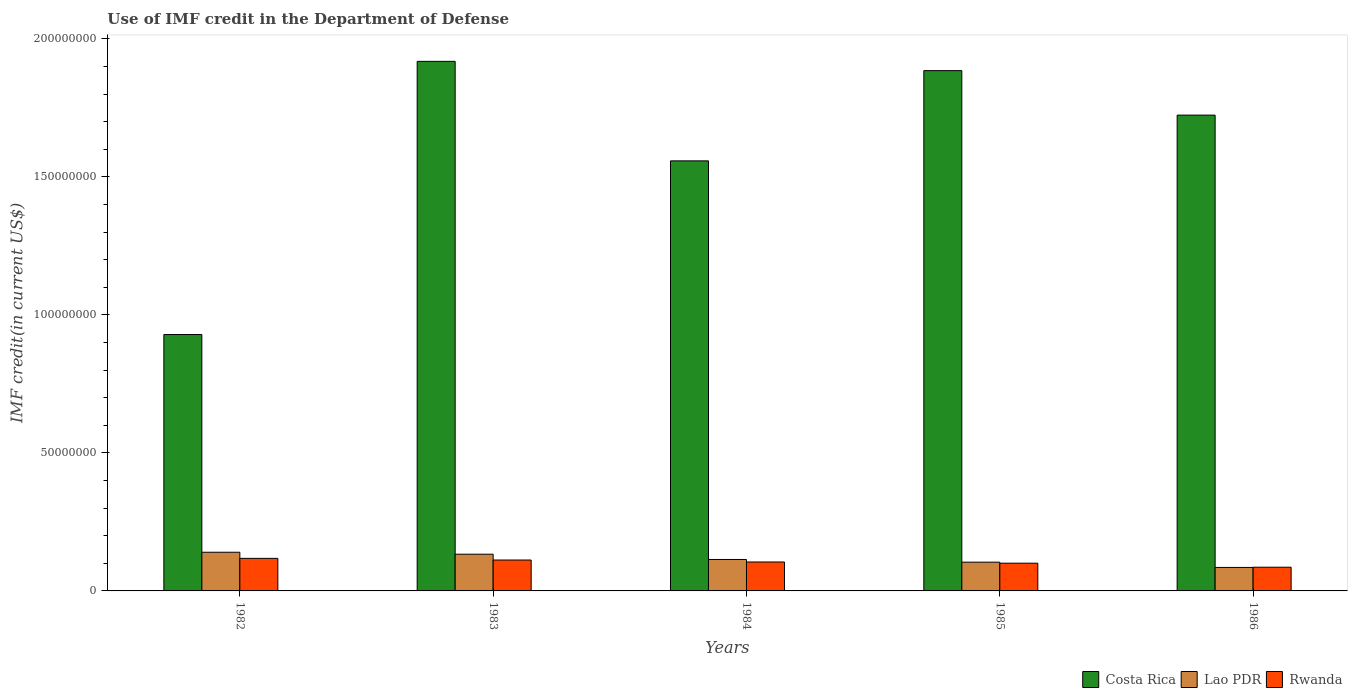How many groups of bars are there?
Provide a succinct answer. 5. Are the number of bars per tick equal to the number of legend labels?
Give a very brief answer. Yes. Are the number of bars on each tick of the X-axis equal?
Ensure brevity in your answer.  Yes. How many bars are there on the 4th tick from the right?
Provide a short and direct response. 3. In how many cases, is the number of bars for a given year not equal to the number of legend labels?
Ensure brevity in your answer.  0. What is the IMF credit in the Department of Defense in Lao PDR in 1985?
Ensure brevity in your answer.  1.04e+07. Across all years, what is the maximum IMF credit in the Department of Defense in Rwanda?
Offer a terse response. 1.18e+07. Across all years, what is the minimum IMF credit in the Department of Defense in Costa Rica?
Your response must be concise. 9.29e+07. In which year was the IMF credit in the Department of Defense in Costa Rica minimum?
Keep it short and to the point. 1982. What is the total IMF credit in the Department of Defense in Lao PDR in the graph?
Provide a succinct answer. 5.76e+07. What is the difference between the IMF credit in the Department of Defense in Lao PDR in 1982 and that in 1985?
Ensure brevity in your answer.  3.59e+06. What is the difference between the IMF credit in the Department of Defense in Costa Rica in 1985 and the IMF credit in the Department of Defense in Lao PDR in 1984?
Give a very brief answer. 1.77e+08. What is the average IMF credit in the Department of Defense in Costa Rica per year?
Offer a very short reply. 1.60e+08. In the year 1985, what is the difference between the IMF credit in the Department of Defense in Costa Rica and IMF credit in the Department of Defense in Rwanda?
Offer a terse response. 1.78e+08. In how many years, is the IMF credit in the Department of Defense in Rwanda greater than 150000000 US$?
Offer a very short reply. 0. What is the ratio of the IMF credit in the Department of Defense in Costa Rica in 1983 to that in 1985?
Offer a terse response. 1.02. Is the IMF credit in the Department of Defense in Costa Rica in 1982 less than that in 1984?
Make the answer very short. Yes. What is the difference between the highest and the second highest IMF credit in the Department of Defense in Costa Rica?
Your answer should be compact. 3.36e+06. What is the difference between the highest and the lowest IMF credit in the Department of Defense in Rwanda?
Offer a very short reply. 3.20e+06. In how many years, is the IMF credit in the Department of Defense in Rwanda greater than the average IMF credit in the Department of Defense in Rwanda taken over all years?
Your response must be concise. 3. What does the 1st bar from the left in 1984 represents?
Your answer should be compact. Costa Rica. What does the 2nd bar from the right in 1986 represents?
Keep it short and to the point. Lao PDR. Is it the case that in every year, the sum of the IMF credit in the Department of Defense in Costa Rica and IMF credit in the Department of Defense in Rwanda is greater than the IMF credit in the Department of Defense in Lao PDR?
Offer a very short reply. Yes. How many bars are there?
Your answer should be compact. 15. Are all the bars in the graph horizontal?
Give a very brief answer. No. What is the difference between two consecutive major ticks on the Y-axis?
Your answer should be very brief. 5.00e+07. Does the graph contain any zero values?
Keep it short and to the point. No. Does the graph contain grids?
Offer a terse response. No. Where does the legend appear in the graph?
Your answer should be very brief. Bottom right. How are the legend labels stacked?
Ensure brevity in your answer.  Horizontal. What is the title of the graph?
Provide a short and direct response. Use of IMF credit in the Department of Defense. What is the label or title of the X-axis?
Provide a short and direct response. Years. What is the label or title of the Y-axis?
Offer a very short reply. IMF credit(in current US$). What is the IMF credit(in current US$) of Costa Rica in 1982?
Keep it short and to the point. 9.29e+07. What is the IMF credit(in current US$) of Lao PDR in 1982?
Your answer should be very brief. 1.40e+07. What is the IMF credit(in current US$) of Rwanda in 1982?
Provide a succinct answer. 1.18e+07. What is the IMF credit(in current US$) of Costa Rica in 1983?
Provide a succinct answer. 1.92e+08. What is the IMF credit(in current US$) in Lao PDR in 1983?
Make the answer very short. 1.33e+07. What is the IMF credit(in current US$) of Rwanda in 1983?
Make the answer very short. 1.12e+07. What is the IMF credit(in current US$) of Costa Rica in 1984?
Ensure brevity in your answer.  1.56e+08. What is the IMF credit(in current US$) of Lao PDR in 1984?
Keep it short and to the point. 1.14e+07. What is the IMF credit(in current US$) in Rwanda in 1984?
Give a very brief answer. 1.05e+07. What is the IMF credit(in current US$) of Costa Rica in 1985?
Ensure brevity in your answer.  1.89e+08. What is the IMF credit(in current US$) of Lao PDR in 1985?
Provide a succinct answer. 1.04e+07. What is the IMF credit(in current US$) in Rwanda in 1985?
Provide a short and direct response. 1.00e+07. What is the IMF credit(in current US$) of Costa Rica in 1986?
Offer a very short reply. 1.72e+08. What is the IMF credit(in current US$) of Lao PDR in 1986?
Keep it short and to the point. 8.51e+06. What is the IMF credit(in current US$) in Rwanda in 1986?
Keep it short and to the point. 8.59e+06. Across all years, what is the maximum IMF credit(in current US$) of Costa Rica?
Ensure brevity in your answer.  1.92e+08. Across all years, what is the maximum IMF credit(in current US$) in Lao PDR?
Your answer should be very brief. 1.40e+07. Across all years, what is the maximum IMF credit(in current US$) in Rwanda?
Ensure brevity in your answer.  1.18e+07. Across all years, what is the minimum IMF credit(in current US$) of Costa Rica?
Keep it short and to the point. 9.29e+07. Across all years, what is the minimum IMF credit(in current US$) in Lao PDR?
Your answer should be compact. 8.51e+06. Across all years, what is the minimum IMF credit(in current US$) in Rwanda?
Your response must be concise. 8.59e+06. What is the total IMF credit(in current US$) of Costa Rica in the graph?
Give a very brief answer. 8.02e+08. What is the total IMF credit(in current US$) in Lao PDR in the graph?
Offer a terse response. 5.76e+07. What is the total IMF credit(in current US$) in Rwanda in the graph?
Your response must be concise. 5.21e+07. What is the difference between the IMF credit(in current US$) of Costa Rica in 1982 and that in 1983?
Ensure brevity in your answer.  -9.90e+07. What is the difference between the IMF credit(in current US$) in Lao PDR in 1982 and that in 1983?
Make the answer very short. 7.14e+05. What is the difference between the IMF credit(in current US$) in Rwanda in 1982 and that in 1983?
Your response must be concise. 6.01e+05. What is the difference between the IMF credit(in current US$) of Costa Rica in 1982 and that in 1984?
Offer a very short reply. -6.29e+07. What is the difference between the IMF credit(in current US$) in Lao PDR in 1982 and that in 1984?
Provide a short and direct response. 2.62e+06. What is the difference between the IMF credit(in current US$) of Rwanda in 1982 and that in 1984?
Your response must be concise. 1.32e+06. What is the difference between the IMF credit(in current US$) in Costa Rica in 1982 and that in 1985?
Keep it short and to the point. -9.56e+07. What is the difference between the IMF credit(in current US$) of Lao PDR in 1982 and that in 1985?
Keep it short and to the point. 3.59e+06. What is the difference between the IMF credit(in current US$) of Rwanda in 1982 and that in 1985?
Make the answer very short. 1.75e+06. What is the difference between the IMF credit(in current US$) of Costa Rica in 1982 and that in 1986?
Provide a short and direct response. -7.95e+07. What is the difference between the IMF credit(in current US$) in Lao PDR in 1982 and that in 1986?
Provide a short and direct response. 5.50e+06. What is the difference between the IMF credit(in current US$) of Rwanda in 1982 and that in 1986?
Ensure brevity in your answer.  3.20e+06. What is the difference between the IMF credit(in current US$) in Costa Rica in 1983 and that in 1984?
Make the answer very short. 3.61e+07. What is the difference between the IMF credit(in current US$) in Lao PDR in 1983 and that in 1984?
Keep it short and to the point. 1.90e+06. What is the difference between the IMF credit(in current US$) of Rwanda in 1983 and that in 1984?
Your answer should be very brief. 7.14e+05. What is the difference between the IMF credit(in current US$) in Costa Rica in 1983 and that in 1985?
Offer a very short reply. 3.36e+06. What is the difference between the IMF credit(in current US$) of Lao PDR in 1983 and that in 1985?
Keep it short and to the point. 2.88e+06. What is the difference between the IMF credit(in current US$) in Rwanda in 1983 and that in 1985?
Make the answer very short. 1.15e+06. What is the difference between the IMF credit(in current US$) of Costa Rica in 1983 and that in 1986?
Give a very brief answer. 1.95e+07. What is the difference between the IMF credit(in current US$) of Lao PDR in 1983 and that in 1986?
Offer a terse response. 4.79e+06. What is the difference between the IMF credit(in current US$) in Rwanda in 1983 and that in 1986?
Keep it short and to the point. 2.60e+06. What is the difference between the IMF credit(in current US$) in Costa Rica in 1984 and that in 1985?
Ensure brevity in your answer.  -3.27e+07. What is the difference between the IMF credit(in current US$) in Lao PDR in 1984 and that in 1985?
Ensure brevity in your answer.  9.73e+05. What is the difference between the IMF credit(in current US$) in Rwanda in 1984 and that in 1985?
Offer a very short reply. 4.35e+05. What is the difference between the IMF credit(in current US$) of Costa Rica in 1984 and that in 1986?
Make the answer very short. -1.66e+07. What is the difference between the IMF credit(in current US$) in Lao PDR in 1984 and that in 1986?
Offer a terse response. 2.88e+06. What is the difference between the IMF credit(in current US$) in Rwanda in 1984 and that in 1986?
Your response must be concise. 1.89e+06. What is the difference between the IMF credit(in current US$) in Costa Rica in 1985 and that in 1986?
Provide a succinct answer. 1.61e+07. What is the difference between the IMF credit(in current US$) of Lao PDR in 1985 and that in 1986?
Provide a short and direct response. 1.91e+06. What is the difference between the IMF credit(in current US$) in Rwanda in 1985 and that in 1986?
Offer a terse response. 1.46e+06. What is the difference between the IMF credit(in current US$) in Costa Rica in 1982 and the IMF credit(in current US$) in Lao PDR in 1983?
Provide a short and direct response. 7.96e+07. What is the difference between the IMF credit(in current US$) of Costa Rica in 1982 and the IMF credit(in current US$) of Rwanda in 1983?
Your response must be concise. 8.17e+07. What is the difference between the IMF credit(in current US$) in Lao PDR in 1982 and the IMF credit(in current US$) in Rwanda in 1983?
Your answer should be very brief. 2.82e+06. What is the difference between the IMF credit(in current US$) in Costa Rica in 1982 and the IMF credit(in current US$) in Lao PDR in 1984?
Offer a terse response. 8.15e+07. What is the difference between the IMF credit(in current US$) of Costa Rica in 1982 and the IMF credit(in current US$) of Rwanda in 1984?
Offer a terse response. 8.24e+07. What is the difference between the IMF credit(in current US$) of Lao PDR in 1982 and the IMF credit(in current US$) of Rwanda in 1984?
Offer a terse response. 3.53e+06. What is the difference between the IMF credit(in current US$) in Costa Rica in 1982 and the IMF credit(in current US$) in Lao PDR in 1985?
Your response must be concise. 8.25e+07. What is the difference between the IMF credit(in current US$) of Costa Rica in 1982 and the IMF credit(in current US$) of Rwanda in 1985?
Make the answer very short. 8.29e+07. What is the difference between the IMF credit(in current US$) in Lao PDR in 1982 and the IMF credit(in current US$) in Rwanda in 1985?
Make the answer very short. 3.97e+06. What is the difference between the IMF credit(in current US$) in Costa Rica in 1982 and the IMF credit(in current US$) in Lao PDR in 1986?
Ensure brevity in your answer.  8.44e+07. What is the difference between the IMF credit(in current US$) of Costa Rica in 1982 and the IMF credit(in current US$) of Rwanda in 1986?
Keep it short and to the point. 8.43e+07. What is the difference between the IMF credit(in current US$) in Lao PDR in 1982 and the IMF credit(in current US$) in Rwanda in 1986?
Your answer should be very brief. 5.42e+06. What is the difference between the IMF credit(in current US$) in Costa Rica in 1983 and the IMF credit(in current US$) in Lao PDR in 1984?
Offer a very short reply. 1.80e+08. What is the difference between the IMF credit(in current US$) of Costa Rica in 1983 and the IMF credit(in current US$) of Rwanda in 1984?
Make the answer very short. 1.81e+08. What is the difference between the IMF credit(in current US$) in Lao PDR in 1983 and the IMF credit(in current US$) in Rwanda in 1984?
Make the answer very short. 2.82e+06. What is the difference between the IMF credit(in current US$) of Costa Rica in 1983 and the IMF credit(in current US$) of Lao PDR in 1985?
Offer a very short reply. 1.81e+08. What is the difference between the IMF credit(in current US$) in Costa Rica in 1983 and the IMF credit(in current US$) in Rwanda in 1985?
Provide a short and direct response. 1.82e+08. What is the difference between the IMF credit(in current US$) in Lao PDR in 1983 and the IMF credit(in current US$) in Rwanda in 1985?
Offer a terse response. 3.25e+06. What is the difference between the IMF credit(in current US$) of Costa Rica in 1983 and the IMF credit(in current US$) of Lao PDR in 1986?
Ensure brevity in your answer.  1.83e+08. What is the difference between the IMF credit(in current US$) of Costa Rica in 1983 and the IMF credit(in current US$) of Rwanda in 1986?
Provide a short and direct response. 1.83e+08. What is the difference between the IMF credit(in current US$) in Lao PDR in 1983 and the IMF credit(in current US$) in Rwanda in 1986?
Make the answer very short. 4.71e+06. What is the difference between the IMF credit(in current US$) of Costa Rica in 1984 and the IMF credit(in current US$) of Lao PDR in 1985?
Your answer should be compact. 1.45e+08. What is the difference between the IMF credit(in current US$) in Costa Rica in 1984 and the IMF credit(in current US$) in Rwanda in 1985?
Your answer should be compact. 1.46e+08. What is the difference between the IMF credit(in current US$) in Lao PDR in 1984 and the IMF credit(in current US$) in Rwanda in 1985?
Offer a terse response. 1.35e+06. What is the difference between the IMF credit(in current US$) of Costa Rica in 1984 and the IMF credit(in current US$) of Lao PDR in 1986?
Provide a short and direct response. 1.47e+08. What is the difference between the IMF credit(in current US$) in Costa Rica in 1984 and the IMF credit(in current US$) in Rwanda in 1986?
Provide a succinct answer. 1.47e+08. What is the difference between the IMF credit(in current US$) of Lao PDR in 1984 and the IMF credit(in current US$) of Rwanda in 1986?
Provide a succinct answer. 2.80e+06. What is the difference between the IMF credit(in current US$) in Costa Rica in 1985 and the IMF credit(in current US$) in Lao PDR in 1986?
Ensure brevity in your answer.  1.80e+08. What is the difference between the IMF credit(in current US$) of Costa Rica in 1985 and the IMF credit(in current US$) of Rwanda in 1986?
Your answer should be very brief. 1.80e+08. What is the difference between the IMF credit(in current US$) in Lao PDR in 1985 and the IMF credit(in current US$) in Rwanda in 1986?
Keep it short and to the point. 1.83e+06. What is the average IMF credit(in current US$) in Costa Rica per year?
Offer a terse response. 1.60e+08. What is the average IMF credit(in current US$) of Lao PDR per year?
Offer a very short reply. 1.15e+07. What is the average IMF credit(in current US$) of Rwanda per year?
Your response must be concise. 1.04e+07. In the year 1982, what is the difference between the IMF credit(in current US$) of Costa Rica and IMF credit(in current US$) of Lao PDR?
Provide a short and direct response. 7.89e+07. In the year 1982, what is the difference between the IMF credit(in current US$) of Costa Rica and IMF credit(in current US$) of Rwanda?
Offer a terse response. 8.11e+07. In the year 1982, what is the difference between the IMF credit(in current US$) in Lao PDR and IMF credit(in current US$) in Rwanda?
Give a very brief answer. 2.22e+06. In the year 1983, what is the difference between the IMF credit(in current US$) in Costa Rica and IMF credit(in current US$) in Lao PDR?
Keep it short and to the point. 1.79e+08. In the year 1983, what is the difference between the IMF credit(in current US$) in Costa Rica and IMF credit(in current US$) in Rwanda?
Give a very brief answer. 1.81e+08. In the year 1983, what is the difference between the IMF credit(in current US$) of Lao PDR and IMF credit(in current US$) of Rwanda?
Provide a succinct answer. 2.10e+06. In the year 1984, what is the difference between the IMF credit(in current US$) in Costa Rica and IMF credit(in current US$) in Lao PDR?
Give a very brief answer. 1.44e+08. In the year 1984, what is the difference between the IMF credit(in current US$) of Costa Rica and IMF credit(in current US$) of Rwanda?
Keep it short and to the point. 1.45e+08. In the year 1984, what is the difference between the IMF credit(in current US$) in Lao PDR and IMF credit(in current US$) in Rwanda?
Your answer should be compact. 9.15e+05. In the year 1985, what is the difference between the IMF credit(in current US$) in Costa Rica and IMF credit(in current US$) in Lao PDR?
Keep it short and to the point. 1.78e+08. In the year 1985, what is the difference between the IMF credit(in current US$) in Costa Rica and IMF credit(in current US$) in Rwanda?
Offer a very short reply. 1.78e+08. In the year 1985, what is the difference between the IMF credit(in current US$) of Lao PDR and IMF credit(in current US$) of Rwanda?
Offer a very short reply. 3.77e+05. In the year 1986, what is the difference between the IMF credit(in current US$) in Costa Rica and IMF credit(in current US$) in Lao PDR?
Provide a short and direct response. 1.64e+08. In the year 1986, what is the difference between the IMF credit(in current US$) of Costa Rica and IMF credit(in current US$) of Rwanda?
Keep it short and to the point. 1.64e+08. In the year 1986, what is the difference between the IMF credit(in current US$) of Lao PDR and IMF credit(in current US$) of Rwanda?
Provide a succinct answer. -7.90e+04. What is the ratio of the IMF credit(in current US$) in Costa Rica in 1982 to that in 1983?
Provide a succinct answer. 0.48. What is the ratio of the IMF credit(in current US$) of Lao PDR in 1982 to that in 1983?
Ensure brevity in your answer.  1.05. What is the ratio of the IMF credit(in current US$) in Rwanda in 1982 to that in 1983?
Ensure brevity in your answer.  1.05. What is the ratio of the IMF credit(in current US$) in Costa Rica in 1982 to that in 1984?
Offer a very short reply. 0.6. What is the ratio of the IMF credit(in current US$) in Lao PDR in 1982 to that in 1984?
Your response must be concise. 1.23. What is the ratio of the IMF credit(in current US$) of Rwanda in 1982 to that in 1984?
Provide a succinct answer. 1.13. What is the ratio of the IMF credit(in current US$) of Costa Rica in 1982 to that in 1985?
Provide a short and direct response. 0.49. What is the ratio of the IMF credit(in current US$) in Lao PDR in 1982 to that in 1985?
Offer a very short reply. 1.34. What is the ratio of the IMF credit(in current US$) in Rwanda in 1982 to that in 1985?
Offer a very short reply. 1.17. What is the ratio of the IMF credit(in current US$) in Costa Rica in 1982 to that in 1986?
Offer a very short reply. 0.54. What is the ratio of the IMF credit(in current US$) of Lao PDR in 1982 to that in 1986?
Give a very brief answer. 1.65. What is the ratio of the IMF credit(in current US$) in Rwanda in 1982 to that in 1986?
Provide a succinct answer. 1.37. What is the ratio of the IMF credit(in current US$) in Costa Rica in 1983 to that in 1984?
Make the answer very short. 1.23. What is the ratio of the IMF credit(in current US$) of Lao PDR in 1983 to that in 1984?
Offer a terse response. 1.17. What is the ratio of the IMF credit(in current US$) of Rwanda in 1983 to that in 1984?
Your answer should be compact. 1.07. What is the ratio of the IMF credit(in current US$) of Costa Rica in 1983 to that in 1985?
Provide a short and direct response. 1.02. What is the ratio of the IMF credit(in current US$) in Lao PDR in 1983 to that in 1985?
Your response must be concise. 1.28. What is the ratio of the IMF credit(in current US$) of Rwanda in 1983 to that in 1985?
Offer a terse response. 1.11. What is the ratio of the IMF credit(in current US$) in Costa Rica in 1983 to that in 1986?
Keep it short and to the point. 1.11. What is the ratio of the IMF credit(in current US$) of Lao PDR in 1983 to that in 1986?
Your response must be concise. 1.56. What is the ratio of the IMF credit(in current US$) of Rwanda in 1983 to that in 1986?
Ensure brevity in your answer.  1.3. What is the ratio of the IMF credit(in current US$) of Costa Rica in 1984 to that in 1985?
Give a very brief answer. 0.83. What is the ratio of the IMF credit(in current US$) in Lao PDR in 1984 to that in 1985?
Ensure brevity in your answer.  1.09. What is the ratio of the IMF credit(in current US$) of Rwanda in 1984 to that in 1985?
Provide a short and direct response. 1.04. What is the ratio of the IMF credit(in current US$) of Costa Rica in 1984 to that in 1986?
Give a very brief answer. 0.9. What is the ratio of the IMF credit(in current US$) of Lao PDR in 1984 to that in 1986?
Provide a short and direct response. 1.34. What is the ratio of the IMF credit(in current US$) in Rwanda in 1984 to that in 1986?
Provide a succinct answer. 1.22. What is the ratio of the IMF credit(in current US$) of Costa Rica in 1985 to that in 1986?
Provide a succinct answer. 1.09. What is the ratio of the IMF credit(in current US$) in Lao PDR in 1985 to that in 1986?
Provide a short and direct response. 1.22. What is the ratio of the IMF credit(in current US$) in Rwanda in 1985 to that in 1986?
Offer a terse response. 1.17. What is the difference between the highest and the second highest IMF credit(in current US$) in Costa Rica?
Offer a terse response. 3.36e+06. What is the difference between the highest and the second highest IMF credit(in current US$) of Lao PDR?
Ensure brevity in your answer.  7.14e+05. What is the difference between the highest and the second highest IMF credit(in current US$) of Rwanda?
Your response must be concise. 6.01e+05. What is the difference between the highest and the lowest IMF credit(in current US$) in Costa Rica?
Give a very brief answer. 9.90e+07. What is the difference between the highest and the lowest IMF credit(in current US$) of Lao PDR?
Keep it short and to the point. 5.50e+06. What is the difference between the highest and the lowest IMF credit(in current US$) of Rwanda?
Your answer should be very brief. 3.20e+06. 